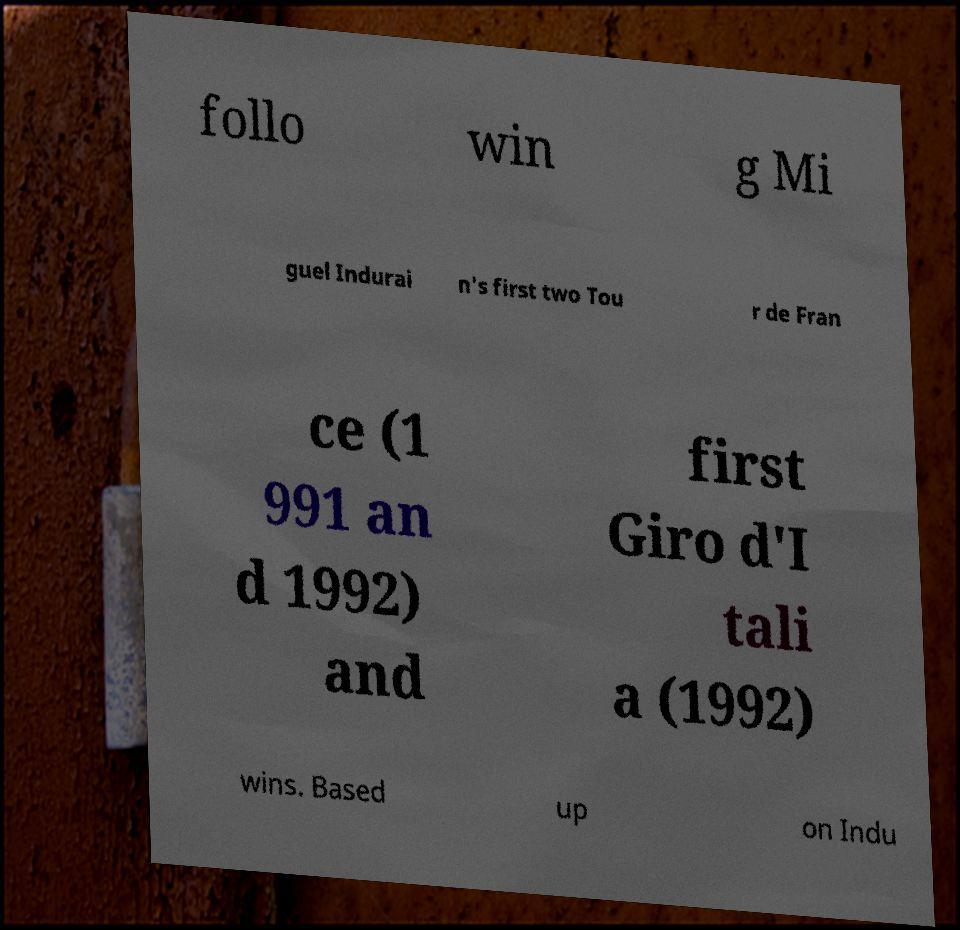What messages or text are displayed in this image? I need them in a readable, typed format. follo win g Mi guel Indurai n's first two Tou r de Fran ce (1 991 an d 1992) and first Giro d'I tali a (1992) wins. Based up on Indu 